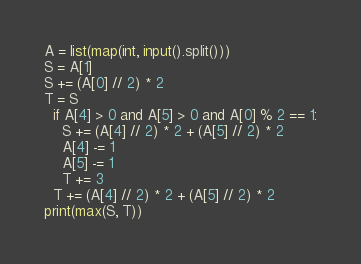Convert code to text. <code><loc_0><loc_0><loc_500><loc_500><_Python_>A = list(map(int, input().split()))
S = A[1]
S += (A[0] // 2) * 2
T = S
  if A[4] > 0 and A[5] > 0 and A[0] % 2 == 1:
    S += (A[4] // 2) * 2 + (A[5] // 2) * 2
    A[4] -= 1
    A[5] -= 1
    T += 3
  T += (A[4] // 2) * 2 + (A[5] // 2) * 2
print(max(S, T))
</code> 